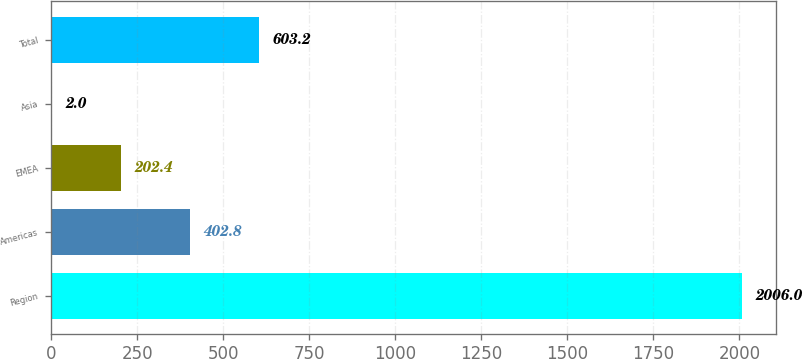Convert chart to OTSL. <chart><loc_0><loc_0><loc_500><loc_500><bar_chart><fcel>Region<fcel>Americas<fcel>EMEA<fcel>Asia<fcel>Total<nl><fcel>2006<fcel>402.8<fcel>202.4<fcel>2<fcel>603.2<nl></chart> 